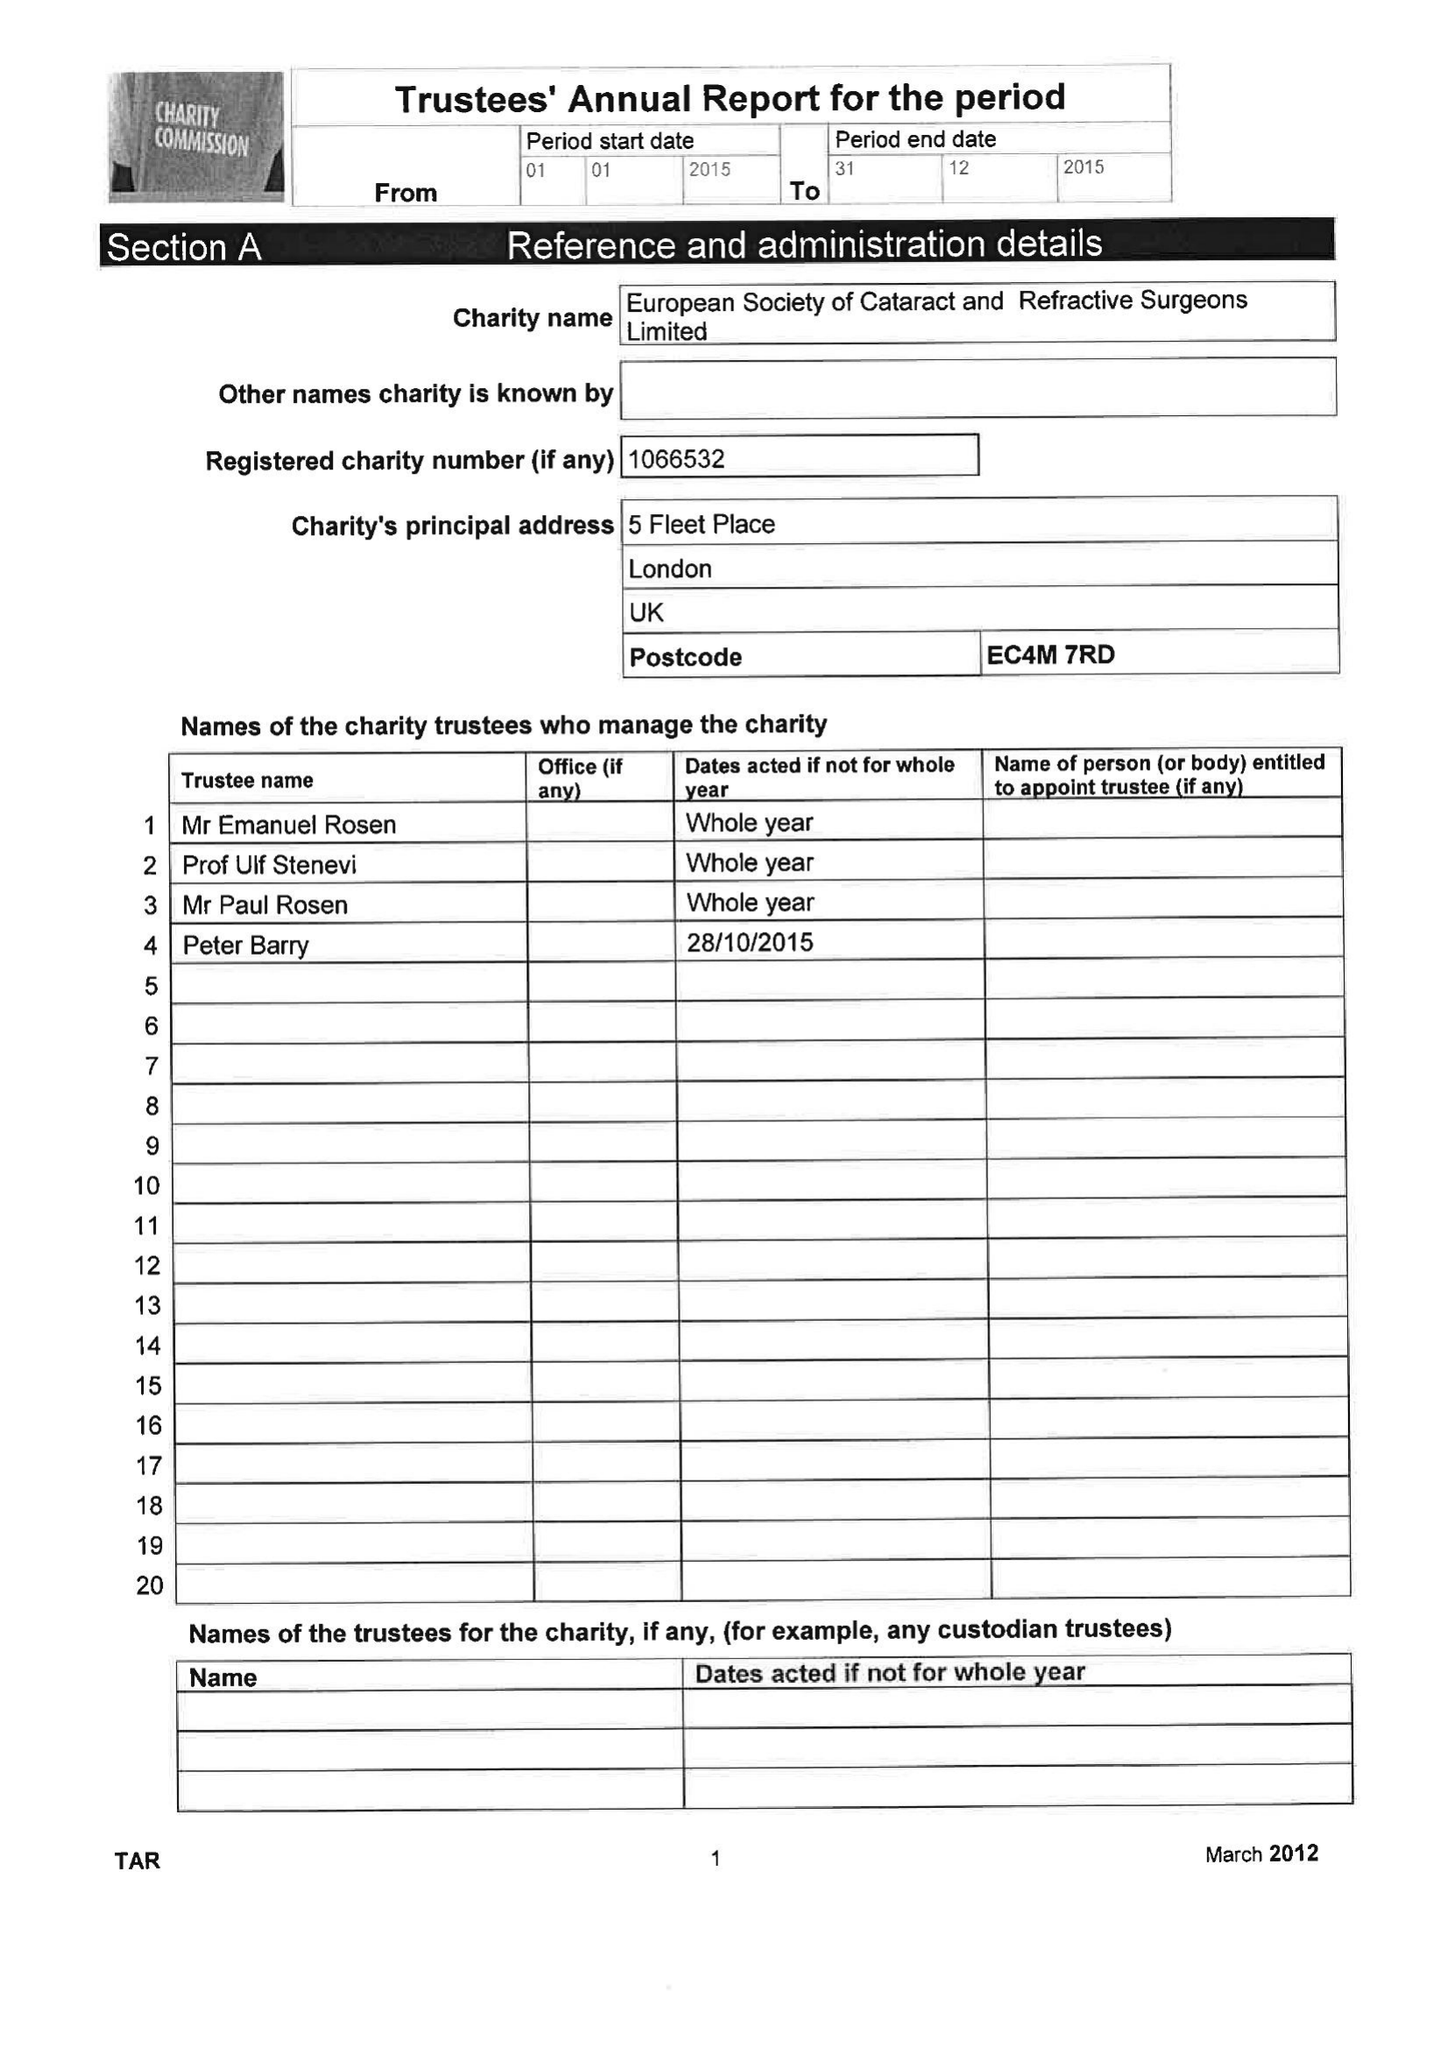What is the value for the charity_number?
Answer the question using a single word or phrase. 1066532 